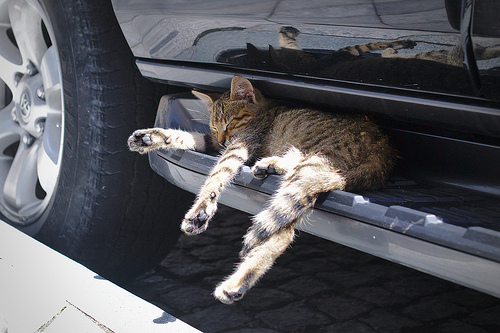<image>
Can you confirm if the cat is in front of the tire? No. The cat is not in front of the tire. The spatial positioning shows a different relationship between these objects. Where is the cat in relation to the car? Is it in front of the car? No. The cat is not in front of the car. The spatial positioning shows a different relationship between these objects. 